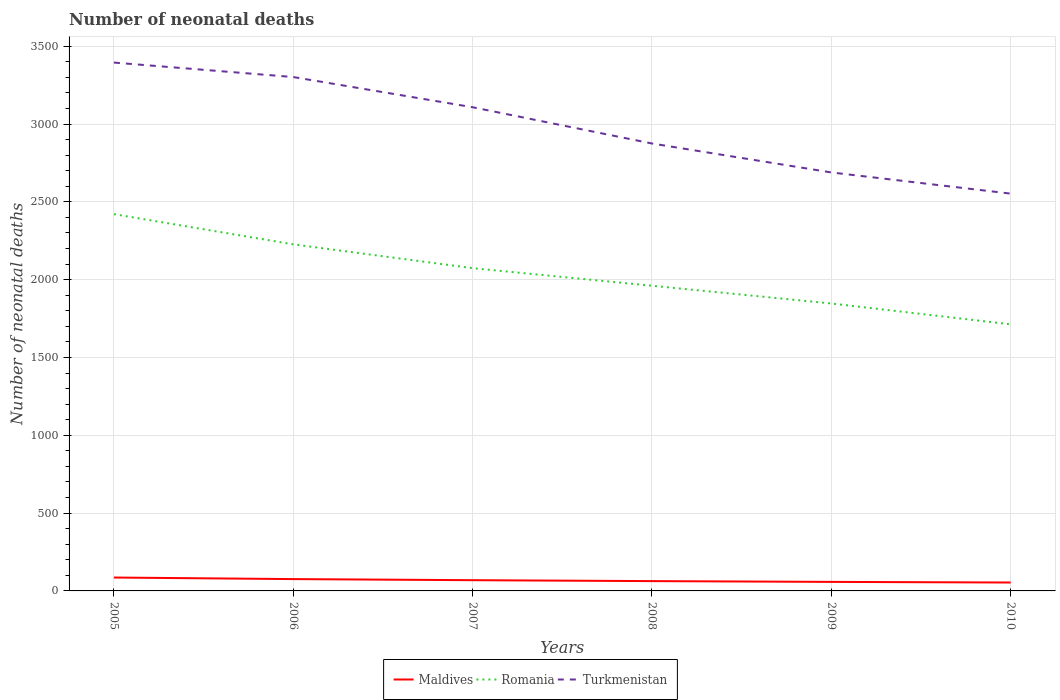How many different coloured lines are there?
Offer a very short reply. 3. Across all years, what is the maximum number of neonatal deaths in in Turkmenistan?
Your response must be concise. 2553. What is the total number of neonatal deaths in in Maldives in the graph?
Offer a very short reply. 23. What is the difference between the highest and the second highest number of neonatal deaths in in Romania?
Offer a terse response. 708. How many lines are there?
Provide a short and direct response. 3. How many years are there in the graph?
Your answer should be compact. 6. What is the difference between two consecutive major ticks on the Y-axis?
Keep it short and to the point. 500. Where does the legend appear in the graph?
Ensure brevity in your answer.  Bottom center. How many legend labels are there?
Make the answer very short. 3. How are the legend labels stacked?
Offer a very short reply. Horizontal. What is the title of the graph?
Give a very brief answer. Number of neonatal deaths. What is the label or title of the Y-axis?
Your answer should be compact. Number of neonatal deaths. What is the Number of neonatal deaths of Romania in 2005?
Make the answer very short. 2421. What is the Number of neonatal deaths in Turkmenistan in 2005?
Provide a succinct answer. 3395. What is the Number of neonatal deaths of Romania in 2006?
Ensure brevity in your answer.  2227. What is the Number of neonatal deaths in Turkmenistan in 2006?
Your response must be concise. 3302. What is the Number of neonatal deaths of Romania in 2007?
Provide a succinct answer. 2074. What is the Number of neonatal deaths of Turkmenistan in 2007?
Offer a very short reply. 3108. What is the Number of neonatal deaths of Romania in 2008?
Give a very brief answer. 1961. What is the Number of neonatal deaths of Turkmenistan in 2008?
Provide a succinct answer. 2875. What is the Number of neonatal deaths of Maldives in 2009?
Ensure brevity in your answer.  58. What is the Number of neonatal deaths of Romania in 2009?
Offer a terse response. 1847. What is the Number of neonatal deaths in Turkmenistan in 2009?
Your answer should be very brief. 2689. What is the Number of neonatal deaths in Maldives in 2010?
Provide a succinct answer. 54. What is the Number of neonatal deaths of Romania in 2010?
Offer a terse response. 1713. What is the Number of neonatal deaths in Turkmenistan in 2010?
Your response must be concise. 2553. Across all years, what is the maximum Number of neonatal deaths of Maldives?
Your answer should be very brief. 86. Across all years, what is the maximum Number of neonatal deaths in Romania?
Your answer should be very brief. 2421. Across all years, what is the maximum Number of neonatal deaths of Turkmenistan?
Your response must be concise. 3395. Across all years, what is the minimum Number of neonatal deaths of Romania?
Your answer should be compact. 1713. Across all years, what is the minimum Number of neonatal deaths in Turkmenistan?
Offer a terse response. 2553. What is the total Number of neonatal deaths in Maldives in the graph?
Provide a succinct answer. 406. What is the total Number of neonatal deaths of Romania in the graph?
Give a very brief answer. 1.22e+04. What is the total Number of neonatal deaths in Turkmenistan in the graph?
Provide a succinct answer. 1.79e+04. What is the difference between the Number of neonatal deaths in Romania in 2005 and that in 2006?
Make the answer very short. 194. What is the difference between the Number of neonatal deaths in Turkmenistan in 2005 and that in 2006?
Your answer should be very brief. 93. What is the difference between the Number of neonatal deaths of Maldives in 2005 and that in 2007?
Give a very brief answer. 17. What is the difference between the Number of neonatal deaths of Romania in 2005 and that in 2007?
Your response must be concise. 347. What is the difference between the Number of neonatal deaths of Turkmenistan in 2005 and that in 2007?
Give a very brief answer. 287. What is the difference between the Number of neonatal deaths in Maldives in 2005 and that in 2008?
Provide a short and direct response. 23. What is the difference between the Number of neonatal deaths of Romania in 2005 and that in 2008?
Provide a succinct answer. 460. What is the difference between the Number of neonatal deaths of Turkmenistan in 2005 and that in 2008?
Provide a succinct answer. 520. What is the difference between the Number of neonatal deaths in Romania in 2005 and that in 2009?
Keep it short and to the point. 574. What is the difference between the Number of neonatal deaths of Turkmenistan in 2005 and that in 2009?
Provide a succinct answer. 706. What is the difference between the Number of neonatal deaths in Maldives in 2005 and that in 2010?
Your answer should be very brief. 32. What is the difference between the Number of neonatal deaths of Romania in 2005 and that in 2010?
Provide a short and direct response. 708. What is the difference between the Number of neonatal deaths in Turkmenistan in 2005 and that in 2010?
Offer a very short reply. 842. What is the difference between the Number of neonatal deaths of Maldives in 2006 and that in 2007?
Keep it short and to the point. 7. What is the difference between the Number of neonatal deaths of Romania in 2006 and that in 2007?
Your answer should be compact. 153. What is the difference between the Number of neonatal deaths of Turkmenistan in 2006 and that in 2007?
Provide a short and direct response. 194. What is the difference between the Number of neonatal deaths of Maldives in 2006 and that in 2008?
Keep it short and to the point. 13. What is the difference between the Number of neonatal deaths in Romania in 2006 and that in 2008?
Offer a terse response. 266. What is the difference between the Number of neonatal deaths in Turkmenistan in 2006 and that in 2008?
Keep it short and to the point. 427. What is the difference between the Number of neonatal deaths of Romania in 2006 and that in 2009?
Keep it short and to the point. 380. What is the difference between the Number of neonatal deaths in Turkmenistan in 2006 and that in 2009?
Offer a terse response. 613. What is the difference between the Number of neonatal deaths of Romania in 2006 and that in 2010?
Give a very brief answer. 514. What is the difference between the Number of neonatal deaths in Turkmenistan in 2006 and that in 2010?
Make the answer very short. 749. What is the difference between the Number of neonatal deaths in Maldives in 2007 and that in 2008?
Ensure brevity in your answer.  6. What is the difference between the Number of neonatal deaths of Romania in 2007 and that in 2008?
Give a very brief answer. 113. What is the difference between the Number of neonatal deaths of Turkmenistan in 2007 and that in 2008?
Provide a succinct answer. 233. What is the difference between the Number of neonatal deaths of Maldives in 2007 and that in 2009?
Provide a short and direct response. 11. What is the difference between the Number of neonatal deaths of Romania in 2007 and that in 2009?
Provide a succinct answer. 227. What is the difference between the Number of neonatal deaths in Turkmenistan in 2007 and that in 2009?
Give a very brief answer. 419. What is the difference between the Number of neonatal deaths in Romania in 2007 and that in 2010?
Provide a short and direct response. 361. What is the difference between the Number of neonatal deaths of Turkmenistan in 2007 and that in 2010?
Give a very brief answer. 555. What is the difference between the Number of neonatal deaths in Romania in 2008 and that in 2009?
Keep it short and to the point. 114. What is the difference between the Number of neonatal deaths in Turkmenistan in 2008 and that in 2009?
Provide a short and direct response. 186. What is the difference between the Number of neonatal deaths in Romania in 2008 and that in 2010?
Make the answer very short. 248. What is the difference between the Number of neonatal deaths of Turkmenistan in 2008 and that in 2010?
Offer a terse response. 322. What is the difference between the Number of neonatal deaths in Maldives in 2009 and that in 2010?
Keep it short and to the point. 4. What is the difference between the Number of neonatal deaths of Romania in 2009 and that in 2010?
Keep it short and to the point. 134. What is the difference between the Number of neonatal deaths in Turkmenistan in 2009 and that in 2010?
Your answer should be very brief. 136. What is the difference between the Number of neonatal deaths of Maldives in 2005 and the Number of neonatal deaths of Romania in 2006?
Your answer should be compact. -2141. What is the difference between the Number of neonatal deaths of Maldives in 2005 and the Number of neonatal deaths of Turkmenistan in 2006?
Make the answer very short. -3216. What is the difference between the Number of neonatal deaths in Romania in 2005 and the Number of neonatal deaths in Turkmenistan in 2006?
Offer a very short reply. -881. What is the difference between the Number of neonatal deaths of Maldives in 2005 and the Number of neonatal deaths of Romania in 2007?
Provide a short and direct response. -1988. What is the difference between the Number of neonatal deaths of Maldives in 2005 and the Number of neonatal deaths of Turkmenistan in 2007?
Your response must be concise. -3022. What is the difference between the Number of neonatal deaths of Romania in 2005 and the Number of neonatal deaths of Turkmenistan in 2007?
Make the answer very short. -687. What is the difference between the Number of neonatal deaths of Maldives in 2005 and the Number of neonatal deaths of Romania in 2008?
Offer a terse response. -1875. What is the difference between the Number of neonatal deaths in Maldives in 2005 and the Number of neonatal deaths in Turkmenistan in 2008?
Provide a succinct answer. -2789. What is the difference between the Number of neonatal deaths in Romania in 2005 and the Number of neonatal deaths in Turkmenistan in 2008?
Provide a succinct answer. -454. What is the difference between the Number of neonatal deaths of Maldives in 2005 and the Number of neonatal deaths of Romania in 2009?
Offer a very short reply. -1761. What is the difference between the Number of neonatal deaths of Maldives in 2005 and the Number of neonatal deaths of Turkmenistan in 2009?
Ensure brevity in your answer.  -2603. What is the difference between the Number of neonatal deaths of Romania in 2005 and the Number of neonatal deaths of Turkmenistan in 2009?
Keep it short and to the point. -268. What is the difference between the Number of neonatal deaths of Maldives in 2005 and the Number of neonatal deaths of Romania in 2010?
Your answer should be very brief. -1627. What is the difference between the Number of neonatal deaths in Maldives in 2005 and the Number of neonatal deaths in Turkmenistan in 2010?
Your answer should be compact. -2467. What is the difference between the Number of neonatal deaths in Romania in 2005 and the Number of neonatal deaths in Turkmenistan in 2010?
Make the answer very short. -132. What is the difference between the Number of neonatal deaths in Maldives in 2006 and the Number of neonatal deaths in Romania in 2007?
Give a very brief answer. -1998. What is the difference between the Number of neonatal deaths in Maldives in 2006 and the Number of neonatal deaths in Turkmenistan in 2007?
Offer a very short reply. -3032. What is the difference between the Number of neonatal deaths in Romania in 2006 and the Number of neonatal deaths in Turkmenistan in 2007?
Your response must be concise. -881. What is the difference between the Number of neonatal deaths in Maldives in 2006 and the Number of neonatal deaths in Romania in 2008?
Offer a terse response. -1885. What is the difference between the Number of neonatal deaths in Maldives in 2006 and the Number of neonatal deaths in Turkmenistan in 2008?
Provide a succinct answer. -2799. What is the difference between the Number of neonatal deaths in Romania in 2006 and the Number of neonatal deaths in Turkmenistan in 2008?
Provide a short and direct response. -648. What is the difference between the Number of neonatal deaths in Maldives in 2006 and the Number of neonatal deaths in Romania in 2009?
Ensure brevity in your answer.  -1771. What is the difference between the Number of neonatal deaths in Maldives in 2006 and the Number of neonatal deaths in Turkmenistan in 2009?
Provide a succinct answer. -2613. What is the difference between the Number of neonatal deaths in Romania in 2006 and the Number of neonatal deaths in Turkmenistan in 2009?
Provide a short and direct response. -462. What is the difference between the Number of neonatal deaths in Maldives in 2006 and the Number of neonatal deaths in Romania in 2010?
Ensure brevity in your answer.  -1637. What is the difference between the Number of neonatal deaths in Maldives in 2006 and the Number of neonatal deaths in Turkmenistan in 2010?
Ensure brevity in your answer.  -2477. What is the difference between the Number of neonatal deaths of Romania in 2006 and the Number of neonatal deaths of Turkmenistan in 2010?
Your answer should be very brief. -326. What is the difference between the Number of neonatal deaths of Maldives in 2007 and the Number of neonatal deaths of Romania in 2008?
Offer a very short reply. -1892. What is the difference between the Number of neonatal deaths of Maldives in 2007 and the Number of neonatal deaths of Turkmenistan in 2008?
Provide a succinct answer. -2806. What is the difference between the Number of neonatal deaths in Romania in 2007 and the Number of neonatal deaths in Turkmenistan in 2008?
Provide a succinct answer. -801. What is the difference between the Number of neonatal deaths of Maldives in 2007 and the Number of neonatal deaths of Romania in 2009?
Provide a short and direct response. -1778. What is the difference between the Number of neonatal deaths of Maldives in 2007 and the Number of neonatal deaths of Turkmenistan in 2009?
Keep it short and to the point. -2620. What is the difference between the Number of neonatal deaths in Romania in 2007 and the Number of neonatal deaths in Turkmenistan in 2009?
Provide a short and direct response. -615. What is the difference between the Number of neonatal deaths in Maldives in 2007 and the Number of neonatal deaths in Romania in 2010?
Offer a terse response. -1644. What is the difference between the Number of neonatal deaths in Maldives in 2007 and the Number of neonatal deaths in Turkmenistan in 2010?
Make the answer very short. -2484. What is the difference between the Number of neonatal deaths of Romania in 2007 and the Number of neonatal deaths of Turkmenistan in 2010?
Give a very brief answer. -479. What is the difference between the Number of neonatal deaths in Maldives in 2008 and the Number of neonatal deaths in Romania in 2009?
Your response must be concise. -1784. What is the difference between the Number of neonatal deaths of Maldives in 2008 and the Number of neonatal deaths of Turkmenistan in 2009?
Your answer should be compact. -2626. What is the difference between the Number of neonatal deaths of Romania in 2008 and the Number of neonatal deaths of Turkmenistan in 2009?
Provide a short and direct response. -728. What is the difference between the Number of neonatal deaths in Maldives in 2008 and the Number of neonatal deaths in Romania in 2010?
Provide a short and direct response. -1650. What is the difference between the Number of neonatal deaths of Maldives in 2008 and the Number of neonatal deaths of Turkmenistan in 2010?
Your answer should be compact. -2490. What is the difference between the Number of neonatal deaths of Romania in 2008 and the Number of neonatal deaths of Turkmenistan in 2010?
Your response must be concise. -592. What is the difference between the Number of neonatal deaths of Maldives in 2009 and the Number of neonatal deaths of Romania in 2010?
Ensure brevity in your answer.  -1655. What is the difference between the Number of neonatal deaths of Maldives in 2009 and the Number of neonatal deaths of Turkmenistan in 2010?
Provide a short and direct response. -2495. What is the difference between the Number of neonatal deaths in Romania in 2009 and the Number of neonatal deaths in Turkmenistan in 2010?
Offer a very short reply. -706. What is the average Number of neonatal deaths of Maldives per year?
Ensure brevity in your answer.  67.67. What is the average Number of neonatal deaths in Romania per year?
Your response must be concise. 2040.5. What is the average Number of neonatal deaths of Turkmenistan per year?
Provide a succinct answer. 2987. In the year 2005, what is the difference between the Number of neonatal deaths of Maldives and Number of neonatal deaths of Romania?
Make the answer very short. -2335. In the year 2005, what is the difference between the Number of neonatal deaths in Maldives and Number of neonatal deaths in Turkmenistan?
Offer a very short reply. -3309. In the year 2005, what is the difference between the Number of neonatal deaths of Romania and Number of neonatal deaths of Turkmenistan?
Your response must be concise. -974. In the year 2006, what is the difference between the Number of neonatal deaths of Maldives and Number of neonatal deaths of Romania?
Give a very brief answer. -2151. In the year 2006, what is the difference between the Number of neonatal deaths of Maldives and Number of neonatal deaths of Turkmenistan?
Provide a succinct answer. -3226. In the year 2006, what is the difference between the Number of neonatal deaths in Romania and Number of neonatal deaths in Turkmenistan?
Your answer should be very brief. -1075. In the year 2007, what is the difference between the Number of neonatal deaths of Maldives and Number of neonatal deaths of Romania?
Your answer should be very brief. -2005. In the year 2007, what is the difference between the Number of neonatal deaths of Maldives and Number of neonatal deaths of Turkmenistan?
Make the answer very short. -3039. In the year 2007, what is the difference between the Number of neonatal deaths in Romania and Number of neonatal deaths in Turkmenistan?
Provide a short and direct response. -1034. In the year 2008, what is the difference between the Number of neonatal deaths in Maldives and Number of neonatal deaths in Romania?
Ensure brevity in your answer.  -1898. In the year 2008, what is the difference between the Number of neonatal deaths of Maldives and Number of neonatal deaths of Turkmenistan?
Your answer should be very brief. -2812. In the year 2008, what is the difference between the Number of neonatal deaths of Romania and Number of neonatal deaths of Turkmenistan?
Offer a very short reply. -914. In the year 2009, what is the difference between the Number of neonatal deaths of Maldives and Number of neonatal deaths of Romania?
Provide a succinct answer. -1789. In the year 2009, what is the difference between the Number of neonatal deaths in Maldives and Number of neonatal deaths in Turkmenistan?
Your answer should be very brief. -2631. In the year 2009, what is the difference between the Number of neonatal deaths of Romania and Number of neonatal deaths of Turkmenistan?
Provide a short and direct response. -842. In the year 2010, what is the difference between the Number of neonatal deaths of Maldives and Number of neonatal deaths of Romania?
Your answer should be very brief. -1659. In the year 2010, what is the difference between the Number of neonatal deaths of Maldives and Number of neonatal deaths of Turkmenistan?
Ensure brevity in your answer.  -2499. In the year 2010, what is the difference between the Number of neonatal deaths of Romania and Number of neonatal deaths of Turkmenistan?
Provide a succinct answer. -840. What is the ratio of the Number of neonatal deaths in Maldives in 2005 to that in 2006?
Offer a very short reply. 1.13. What is the ratio of the Number of neonatal deaths in Romania in 2005 to that in 2006?
Provide a short and direct response. 1.09. What is the ratio of the Number of neonatal deaths of Turkmenistan in 2005 to that in 2006?
Ensure brevity in your answer.  1.03. What is the ratio of the Number of neonatal deaths in Maldives in 2005 to that in 2007?
Ensure brevity in your answer.  1.25. What is the ratio of the Number of neonatal deaths of Romania in 2005 to that in 2007?
Your answer should be very brief. 1.17. What is the ratio of the Number of neonatal deaths in Turkmenistan in 2005 to that in 2007?
Your response must be concise. 1.09. What is the ratio of the Number of neonatal deaths in Maldives in 2005 to that in 2008?
Keep it short and to the point. 1.37. What is the ratio of the Number of neonatal deaths in Romania in 2005 to that in 2008?
Your answer should be very brief. 1.23. What is the ratio of the Number of neonatal deaths in Turkmenistan in 2005 to that in 2008?
Ensure brevity in your answer.  1.18. What is the ratio of the Number of neonatal deaths in Maldives in 2005 to that in 2009?
Provide a short and direct response. 1.48. What is the ratio of the Number of neonatal deaths in Romania in 2005 to that in 2009?
Your answer should be compact. 1.31. What is the ratio of the Number of neonatal deaths of Turkmenistan in 2005 to that in 2009?
Make the answer very short. 1.26. What is the ratio of the Number of neonatal deaths of Maldives in 2005 to that in 2010?
Offer a very short reply. 1.59. What is the ratio of the Number of neonatal deaths of Romania in 2005 to that in 2010?
Your answer should be compact. 1.41. What is the ratio of the Number of neonatal deaths in Turkmenistan in 2005 to that in 2010?
Provide a short and direct response. 1.33. What is the ratio of the Number of neonatal deaths in Maldives in 2006 to that in 2007?
Offer a terse response. 1.1. What is the ratio of the Number of neonatal deaths in Romania in 2006 to that in 2007?
Offer a terse response. 1.07. What is the ratio of the Number of neonatal deaths in Turkmenistan in 2006 to that in 2007?
Your response must be concise. 1.06. What is the ratio of the Number of neonatal deaths of Maldives in 2006 to that in 2008?
Your response must be concise. 1.21. What is the ratio of the Number of neonatal deaths in Romania in 2006 to that in 2008?
Offer a terse response. 1.14. What is the ratio of the Number of neonatal deaths in Turkmenistan in 2006 to that in 2008?
Provide a short and direct response. 1.15. What is the ratio of the Number of neonatal deaths of Maldives in 2006 to that in 2009?
Your answer should be compact. 1.31. What is the ratio of the Number of neonatal deaths of Romania in 2006 to that in 2009?
Your response must be concise. 1.21. What is the ratio of the Number of neonatal deaths in Turkmenistan in 2006 to that in 2009?
Offer a very short reply. 1.23. What is the ratio of the Number of neonatal deaths of Maldives in 2006 to that in 2010?
Make the answer very short. 1.41. What is the ratio of the Number of neonatal deaths of Romania in 2006 to that in 2010?
Your answer should be compact. 1.3. What is the ratio of the Number of neonatal deaths in Turkmenistan in 2006 to that in 2010?
Ensure brevity in your answer.  1.29. What is the ratio of the Number of neonatal deaths of Maldives in 2007 to that in 2008?
Provide a short and direct response. 1.1. What is the ratio of the Number of neonatal deaths of Romania in 2007 to that in 2008?
Offer a terse response. 1.06. What is the ratio of the Number of neonatal deaths in Turkmenistan in 2007 to that in 2008?
Your answer should be very brief. 1.08. What is the ratio of the Number of neonatal deaths of Maldives in 2007 to that in 2009?
Ensure brevity in your answer.  1.19. What is the ratio of the Number of neonatal deaths of Romania in 2007 to that in 2009?
Give a very brief answer. 1.12. What is the ratio of the Number of neonatal deaths of Turkmenistan in 2007 to that in 2009?
Ensure brevity in your answer.  1.16. What is the ratio of the Number of neonatal deaths in Maldives in 2007 to that in 2010?
Keep it short and to the point. 1.28. What is the ratio of the Number of neonatal deaths of Romania in 2007 to that in 2010?
Offer a terse response. 1.21. What is the ratio of the Number of neonatal deaths in Turkmenistan in 2007 to that in 2010?
Keep it short and to the point. 1.22. What is the ratio of the Number of neonatal deaths of Maldives in 2008 to that in 2009?
Make the answer very short. 1.09. What is the ratio of the Number of neonatal deaths of Romania in 2008 to that in 2009?
Provide a short and direct response. 1.06. What is the ratio of the Number of neonatal deaths of Turkmenistan in 2008 to that in 2009?
Your answer should be compact. 1.07. What is the ratio of the Number of neonatal deaths of Maldives in 2008 to that in 2010?
Provide a short and direct response. 1.17. What is the ratio of the Number of neonatal deaths of Romania in 2008 to that in 2010?
Provide a short and direct response. 1.14. What is the ratio of the Number of neonatal deaths of Turkmenistan in 2008 to that in 2010?
Give a very brief answer. 1.13. What is the ratio of the Number of neonatal deaths in Maldives in 2009 to that in 2010?
Give a very brief answer. 1.07. What is the ratio of the Number of neonatal deaths in Romania in 2009 to that in 2010?
Your response must be concise. 1.08. What is the ratio of the Number of neonatal deaths in Turkmenistan in 2009 to that in 2010?
Provide a succinct answer. 1.05. What is the difference between the highest and the second highest Number of neonatal deaths in Romania?
Your response must be concise. 194. What is the difference between the highest and the second highest Number of neonatal deaths in Turkmenistan?
Your answer should be very brief. 93. What is the difference between the highest and the lowest Number of neonatal deaths in Maldives?
Provide a succinct answer. 32. What is the difference between the highest and the lowest Number of neonatal deaths of Romania?
Give a very brief answer. 708. What is the difference between the highest and the lowest Number of neonatal deaths of Turkmenistan?
Keep it short and to the point. 842. 